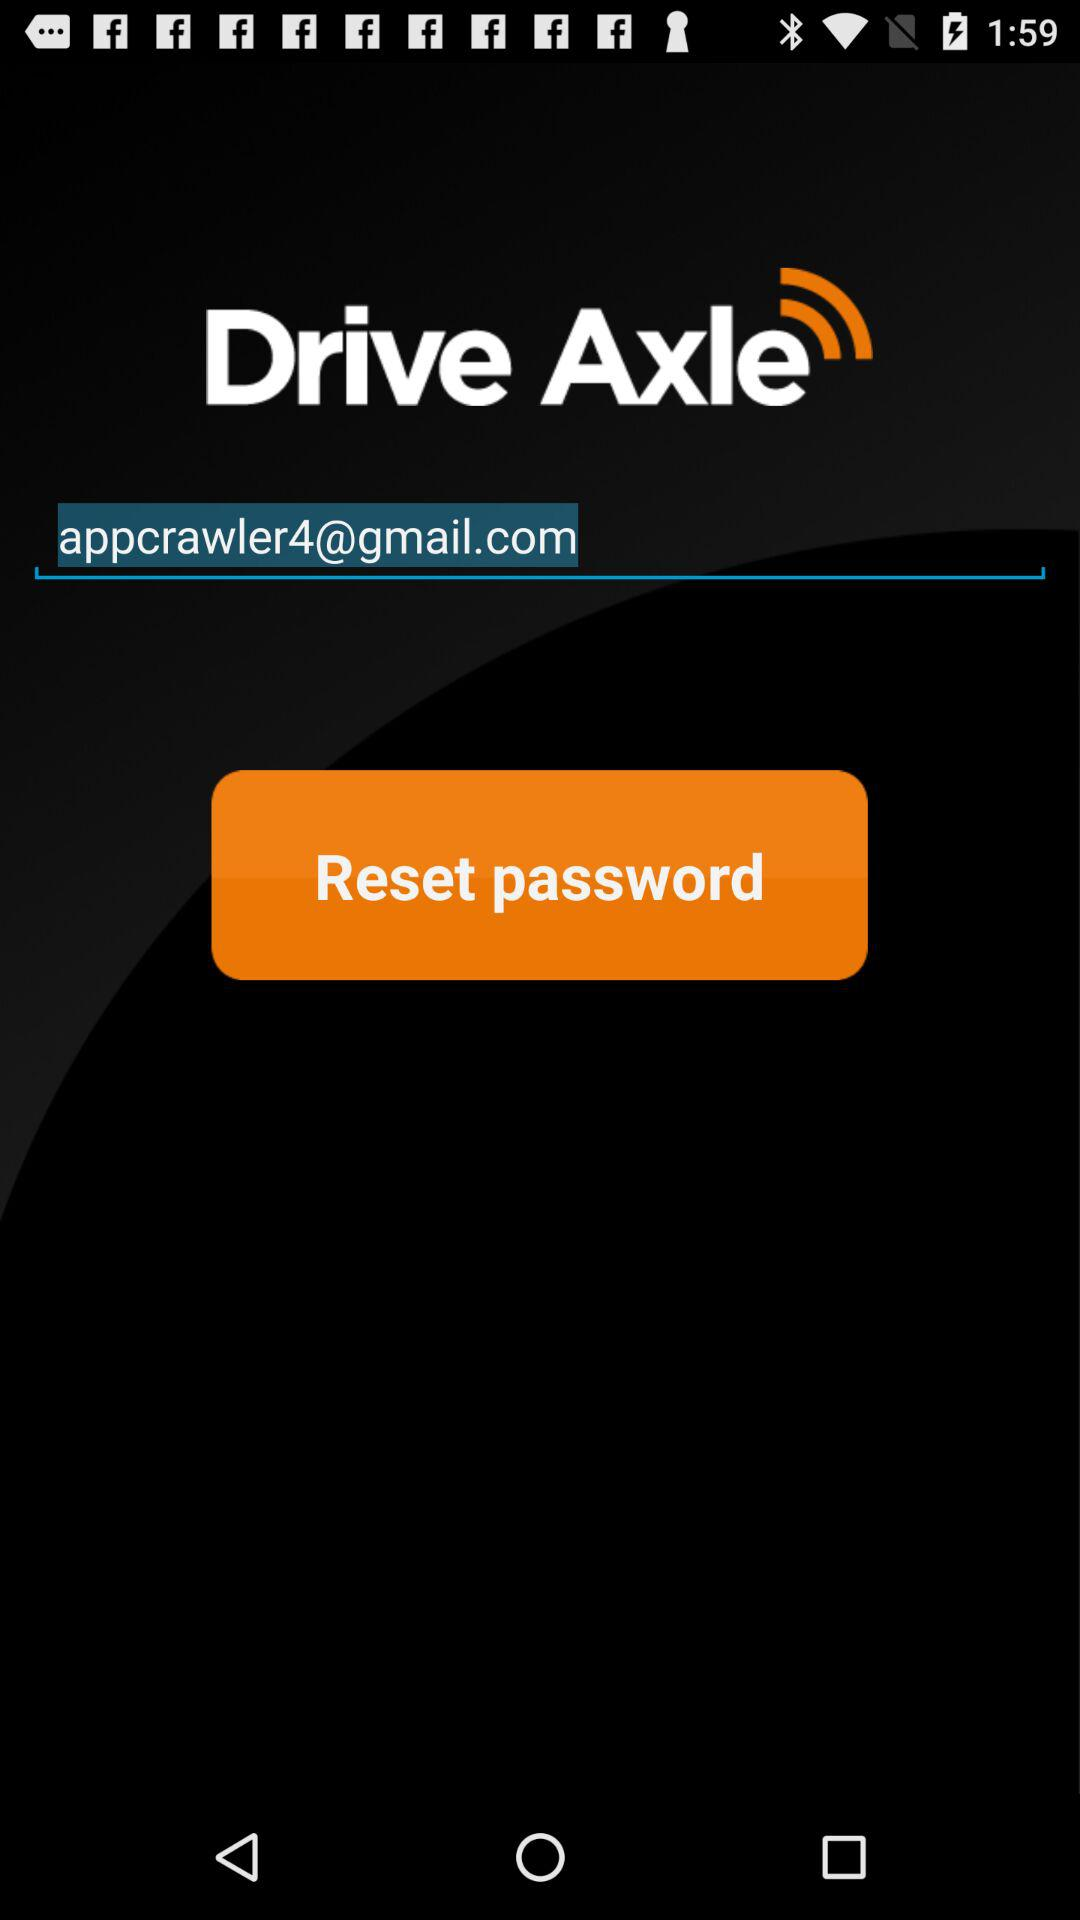What is the email address? The email address is "appcrawler4@gmail.com". 